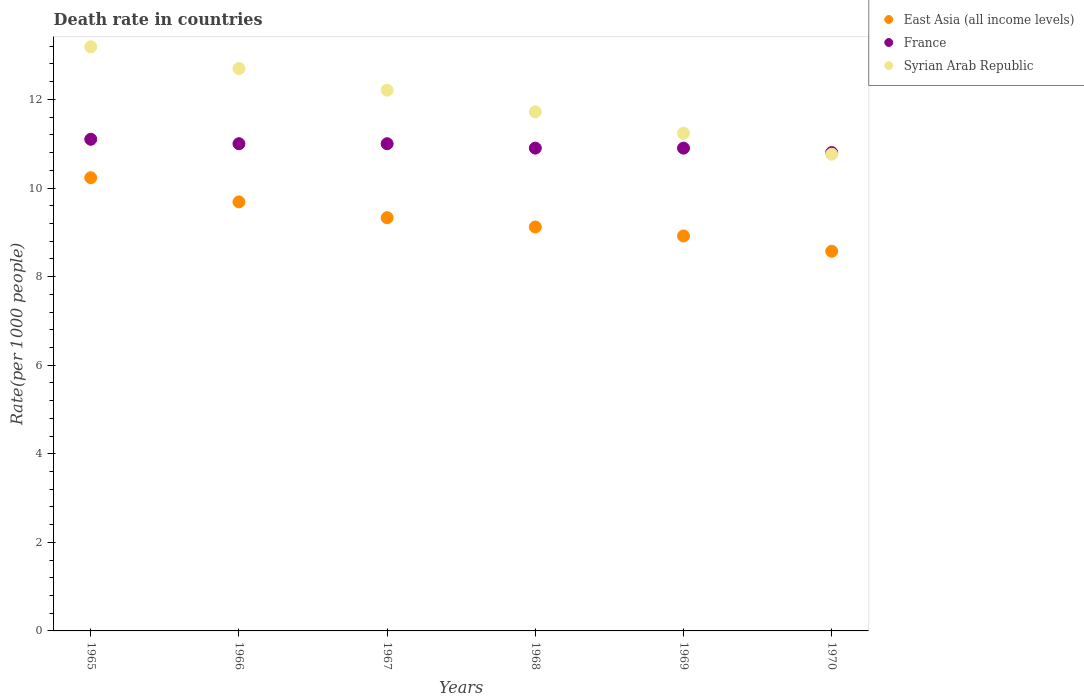What is the death rate in Syrian Arab Republic in 1965?
Offer a terse response. 13.19. Across all years, what is the maximum death rate in East Asia (all income levels)?
Make the answer very short. 10.23. In which year was the death rate in Syrian Arab Republic maximum?
Provide a succinct answer. 1965. What is the total death rate in Syrian Arab Republic in the graph?
Ensure brevity in your answer.  71.81. What is the difference between the death rate in France in 1965 and that in 1969?
Your answer should be very brief. 0.2. What is the difference between the death rate in Syrian Arab Republic in 1967 and the death rate in East Asia (all income levels) in 1968?
Your response must be concise. 3.09. What is the average death rate in Syrian Arab Republic per year?
Provide a succinct answer. 11.97. In the year 1966, what is the difference between the death rate in France and death rate in East Asia (all income levels)?
Provide a succinct answer. 1.31. In how many years, is the death rate in East Asia (all income levels) greater than 10?
Your response must be concise. 1. What is the ratio of the death rate in Syrian Arab Republic in 1966 to that in 1970?
Make the answer very short. 1.18. What is the difference between the highest and the second highest death rate in Syrian Arab Republic?
Give a very brief answer. 0.49. What is the difference between the highest and the lowest death rate in East Asia (all income levels)?
Ensure brevity in your answer.  1.66. Is the sum of the death rate in Syrian Arab Republic in 1969 and 1970 greater than the maximum death rate in France across all years?
Your answer should be very brief. Yes. Is it the case that in every year, the sum of the death rate in France and death rate in East Asia (all income levels)  is greater than the death rate in Syrian Arab Republic?
Make the answer very short. Yes. Does the death rate in East Asia (all income levels) monotonically increase over the years?
Ensure brevity in your answer.  No. Is the death rate in Syrian Arab Republic strictly greater than the death rate in France over the years?
Your response must be concise. No. Is the death rate in France strictly less than the death rate in Syrian Arab Republic over the years?
Your response must be concise. No. How many dotlines are there?
Your answer should be compact. 3. How many years are there in the graph?
Your response must be concise. 6. Where does the legend appear in the graph?
Your answer should be very brief. Top right. How are the legend labels stacked?
Your response must be concise. Vertical. What is the title of the graph?
Provide a succinct answer. Death rate in countries. What is the label or title of the Y-axis?
Your answer should be very brief. Rate(per 1000 people). What is the Rate(per 1000 people) in East Asia (all income levels) in 1965?
Give a very brief answer. 10.23. What is the Rate(per 1000 people) in Syrian Arab Republic in 1965?
Keep it short and to the point. 13.19. What is the Rate(per 1000 people) of East Asia (all income levels) in 1966?
Provide a short and direct response. 9.69. What is the Rate(per 1000 people) of Syrian Arab Republic in 1966?
Offer a terse response. 12.7. What is the Rate(per 1000 people) in East Asia (all income levels) in 1967?
Offer a terse response. 9.33. What is the Rate(per 1000 people) of France in 1967?
Give a very brief answer. 11. What is the Rate(per 1000 people) in Syrian Arab Republic in 1967?
Make the answer very short. 12.21. What is the Rate(per 1000 people) of East Asia (all income levels) in 1968?
Make the answer very short. 9.12. What is the Rate(per 1000 people) in Syrian Arab Republic in 1968?
Provide a short and direct response. 11.72. What is the Rate(per 1000 people) of East Asia (all income levels) in 1969?
Provide a succinct answer. 8.92. What is the Rate(per 1000 people) in France in 1969?
Offer a very short reply. 10.9. What is the Rate(per 1000 people) of Syrian Arab Republic in 1969?
Provide a short and direct response. 11.24. What is the Rate(per 1000 people) in East Asia (all income levels) in 1970?
Your answer should be compact. 8.57. What is the Rate(per 1000 people) in Syrian Arab Republic in 1970?
Your answer should be very brief. 10.76. Across all years, what is the maximum Rate(per 1000 people) in East Asia (all income levels)?
Make the answer very short. 10.23. Across all years, what is the maximum Rate(per 1000 people) of Syrian Arab Republic?
Provide a short and direct response. 13.19. Across all years, what is the minimum Rate(per 1000 people) of East Asia (all income levels)?
Your answer should be compact. 8.57. Across all years, what is the minimum Rate(per 1000 people) of France?
Offer a very short reply. 10.8. Across all years, what is the minimum Rate(per 1000 people) of Syrian Arab Republic?
Offer a terse response. 10.76. What is the total Rate(per 1000 people) in East Asia (all income levels) in the graph?
Provide a succinct answer. 55.86. What is the total Rate(per 1000 people) of France in the graph?
Your answer should be compact. 65.7. What is the total Rate(per 1000 people) of Syrian Arab Republic in the graph?
Give a very brief answer. 71.81. What is the difference between the Rate(per 1000 people) of East Asia (all income levels) in 1965 and that in 1966?
Your answer should be very brief. 0.55. What is the difference between the Rate(per 1000 people) in Syrian Arab Republic in 1965 and that in 1966?
Your answer should be very brief. 0.49. What is the difference between the Rate(per 1000 people) of East Asia (all income levels) in 1965 and that in 1967?
Offer a terse response. 0.9. What is the difference between the Rate(per 1000 people) in East Asia (all income levels) in 1965 and that in 1968?
Give a very brief answer. 1.11. What is the difference between the Rate(per 1000 people) in France in 1965 and that in 1968?
Your answer should be compact. 0.2. What is the difference between the Rate(per 1000 people) in Syrian Arab Republic in 1965 and that in 1968?
Provide a short and direct response. 1.47. What is the difference between the Rate(per 1000 people) in East Asia (all income levels) in 1965 and that in 1969?
Offer a very short reply. 1.32. What is the difference between the Rate(per 1000 people) of France in 1965 and that in 1969?
Offer a very short reply. 0.2. What is the difference between the Rate(per 1000 people) of Syrian Arab Republic in 1965 and that in 1969?
Your answer should be very brief. 1.95. What is the difference between the Rate(per 1000 people) in East Asia (all income levels) in 1965 and that in 1970?
Your response must be concise. 1.66. What is the difference between the Rate(per 1000 people) of Syrian Arab Republic in 1965 and that in 1970?
Offer a terse response. 2.42. What is the difference between the Rate(per 1000 people) of East Asia (all income levels) in 1966 and that in 1967?
Your response must be concise. 0.36. What is the difference between the Rate(per 1000 people) of Syrian Arab Republic in 1966 and that in 1967?
Provide a short and direct response. 0.49. What is the difference between the Rate(per 1000 people) in East Asia (all income levels) in 1966 and that in 1968?
Provide a succinct answer. 0.57. What is the difference between the Rate(per 1000 people) in East Asia (all income levels) in 1966 and that in 1969?
Make the answer very short. 0.77. What is the difference between the Rate(per 1000 people) of Syrian Arab Republic in 1966 and that in 1969?
Offer a terse response. 1.46. What is the difference between the Rate(per 1000 people) of East Asia (all income levels) in 1966 and that in 1970?
Provide a short and direct response. 1.11. What is the difference between the Rate(per 1000 people) of France in 1966 and that in 1970?
Give a very brief answer. 0.2. What is the difference between the Rate(per 1000 people) of Syrian Arab Republic in 1966 and that in 1970?
Keep it short and to the point. 1.93. What is the difference between the Rate(per 1000 people) in East Asia (all income levels) in 1967 and that in 1968?
Ensure brevity in your answer.  0.21. What is the difference between the Rate(per 1000 people) of Syrian Arab Republic in 1967 and that in 1968?
Offer a terse response. 0.49. What is the difference between the Rate(per 1000 people) of East Asia (all income levels) in 1967 and that in 1969?
Make the answer very short. 0.41. What is the difference between the Rate(per 1000 people) in France in 1967 and that in 1969?
Your answer should be compact. 0.1. What is the difference between the Rate(per 1000 people) of Syrian Arab Republic in 1967 and that in 1969?
Your answer should be compact. 0.97. What is the difference between the Rate(per 1000 people) of East Asia (all income levels) in 1967 and that in 1970?
Your answer should be very brief. 0.76. What is the difference between the Rate(per 1000 people) in Syrian Arab Republic in 1967 and that in 1970?
Your answer should be very brief. 1.45. What is the difference between the Rate(per 1000 people) of East Asia (all income levels) in 1968 and that in 1969?
Offer a very short reply. 0.2. What is the difference between the Rate(per 1000 people) in Syrian Arab Republic in 1968 and that in 1969?
Ensure brevity in your answer.  0.48. What is the difference between the Rate(per 1000 people) in East Asia (all income levels) in 1968 and that in 1970?
Offer a very short reply. 0.55. What is the difference between the Rate(per 1000 people) of France in 1968 and that in 1970?
Provide a short and direct response. 0.1. What is the difference between the Rate(per 1000 people) of East Asia (all income levels) in 1969 and that in 1970?
Your response must be concise. 0.35. What is the difference between the Rate(per 1000 people) in Syrian Arab Republic in 1969 and that in 1970?
Ensure brevity in your answer.  0.47. What is the difference between the Rate(per 1000 people) in East Asia (all income levels) in 1965 and the Rate(per 1000 people) in France in 1966?
Your answer should be compact. -0.77. What is the difference between the Rate(per 1000 people) of East Asia (all income levels) in 1965 and the Rate(per 1000 people) of Syrian Arab Republic in 1966?
Give a very brief answer. -2.46. What is the difference between the Rate(per 1000 people) of France in 1965 and the Rate(per 1000 people) of Syrian Arab Republic in 1966?
Your answer should be very brief. -1.6. What is the difference between the Rate(per 1000 people) of East Asia (all income levels) in 1965 and the Rate(per 1000 people) of France in 1967?
Keep it short and to the point. -0.77. What is the difference between the Rate(per 1000 people) of East Asia (all income levels) in 1965 and the Rate(per 1000 people) of Syrian Arab Republic in 1967?
Your answer should be compact. -1.98. What is the difference between the Rate(per 1000 people) in France in 1965 and the Rate(per 1000 people) in Syrian Arab Republic in 1967?
Make the answer very short. -1.11. What is the difference between the Rate(per 1000 people) in East Asia (all income levels) in 1965 and the Rate(per 1000 people) in France in 1968?
Offer a terse response. -0.67. What is the difference between the Rate(per 1000 people) in East Asia (all income levels) in 1965 and the Rate(per 1000 people) in Syrian Arab Republic in 1968?
Offer a terse response. -1.49. What is the difference between the Rate(per 1000 people) in France in 1965 and the Rate(per 1000 people) in Syrian Arab Republic in 1968?
Provide a succinct answer. -0.62. What is the difference between the Rate(per 1000 people) of East Asia (all income levels) in 1965 and the Rate(per 1000 people) of France in 1969?
Make the answer very short. -0.67. What is the difference between the Rate(per 1000 people) of East Asia (all income levels) in 1965 and the Rate(per 1000 people) of Syrian Arab Republic in 1969?
Your answer should be very brief. -1. What is the difference between the Rate(per 1000 people) of France in 1965 and the Rate(per 1000 people) of Syrian Arab Republic in 1969?
Give a very brief answer. -0.14. What is the difference between the Rate(per 1000 people) in East Asia (all income levels) in 1965 and the Rate(per 1000 people) in France in 1970?
Your response must be concise. -0.57. What is the difference between the Rate(per 1000 people) of East Asia (all income levels) in 1965 and the Rate(per 1000 people) of Syrian Arab Republic in 1970?
Offer a very short reply. -0.53. What is the difference between the Rate(per 1000 people) in France in 1965 and the Rate(per 1000 people) in Syrian Arab Republic in 1970?
Offer a very short reply. 0.34. What is the difference between the Rate(per 1000 people) of East Asia (all income levels) in 1966 and the Rate(per 1000 people) of France in 1967?
Your answer should be compact. -1.31. What is the difference between the Rate(per 1000 people) in East Asia (all income levels) in 1966 and the Rate(per 1000 people) in Syrian Arab Republic in 1967?
Offer a terse response. -2.52. What is the difference between the Rate(per 1000 people) of France in 1966 and the Rate(per 1000 people) of Syrian Arab Republic in 1967?
Offer a very short reply. -1.21. What is the difference between the Rate(per 1000 people) of East Asia (all income levels) in 1966 and the Rate(per 1000 people) of France in 1968?
Provide a succinct answer. -1.21. What is the difference between the Rate(per 1000 people) of East Asia (all income levels) in 1966 and the Rate(per 1000 people) of Syrian Arab Republic in 1968?
Offer a terse response. -2.03. What is the difference between the Rate(per 1000 people) of France in 1966 and the Rate(per 1000 people) of Syrian Arab Republic in 1968?
Your response must be concise. -0.72. What is the difference between the Rate(per 1000 people) in East Asia (all income levels) in 1966 and the Rate(per 1000 people) in France in 1969?
Your response must be concise. -1.21. What is the difference between the Rate(per 1000 people) in East Asia (all income levels) in 1966 and the Rate(per 1000 people) in Syrian Arab Republic in 1969?
Offer a very short reply. -1.55. What is the difference between the Rate(per 1000 people) in France in 1966 and the Rate(per 1000 people) in Syrian Arab Republic in 1969?
Give a very brief answer. -0.24. What is the difference between the Rate(per 1000 people) of East Asia (all income levels) in 1966 and the Rate(per 1000 people) of France in 1970?
Keep it short and to the point. -1.11. What is the difference between the Rate(per 1000 people) in East Asia (all income levels) in 1966 and the Rate(per 1000 people) in Syrian Arab Republic in 1970?
Offer a very short reply. -1.08. What is the difference between the Rate(per 1000 people) in France in 1966 and the Rate(per 1000 people) in Syrian Arab Republic in 1970?
Provide a short and direct response. 0.24. What is the difference between the Rate(per 1000 people) of East Asia (all income levels) in 1967 and the Rate(per 1000 people) of France in 1968?
Offer a very short reply. -1.57. What is the difference between the Rate(per 1000 people) of East Asia (all income levels) in 1967 and the Rate(per 1000 people) of Syrian Arab Republic in 1968?
Your answer should be very brief. -2.39. What is the difference between the Rate(per 1000 people) in France in 1967 and the Rate(per 1000 people) in Syrian Arab Republic in 1968?
Provide a short and direct response. -0.72. What is the difference between the Rate(per 1000 people) in East Asia (all income levels) in 1967 and the Rate(per 1000 people) in France in 1969?
Provide a short and direct response. -1.57. What is the difference between the Rate(per 1000 people) of East Asia (all income levels) in 1967 and the Rate(per 1000 people) of Syrian Arab Republic in 1969?
Your answer should be very brief. -1.91. What is the difference between the Rate(per 1000 people) of France in 1967 and the Rate(per 1000 people) of Syrian Arab Republic in 1969?
Offer a very short reply. -0.24. What is the difference between the Rate(per 1000 people) of East Asia (all income levels) in 1967 and the Rate(per 1000 people) of France in 1970?
Offer a very short reply. -1.47. What is the difference between the Rate(per 1000 people) in East Asia (all income levels) in 1967 and the Rate(per 1000 people) in Syrian Arab Republic in 1970?
Make the answer very short. -1.43. What is the difference between the Rate(per 1000 people) in France in 1967 and the Rate(per 1000 people) in Syrian Arab Republic in 1970?
Offer a terse response. 0.24. What is the difference between the Rate(per 1000 people) in East Asia (all income levels) in 1968 and the Rate(per 1000 people) in France in 1969?
Offer a very short reply. -1.78. What is the difference between the Rate(per 1000 people) of East Asia (all income levels) in 1968 and the Rate(per 1000 people) of Syrian Arab Republic in 1969?
Offer a terse response. -2.12. What is the difference between the Rate(per 1000 people) of France in 1968 and the Rate(per 1000 people) of Syrian Arab Republic in 1969?
Make the answer very short. -0.34. What is the difference between the Rate(per 1000 people) of East Asia (all income levels) in 1968 and the Rate(per 1000 people) of France in 1970?
Offer a terse response. -1.68. What is the difference between the Rate(per 1000 people) in East Asia (all income levels) in 1968 and the Rate(per 1000 people) in Syrian Arab Republic in 1970?
Make the answer very short. -1.64. What is the difference between the Rate(per 1000 people) in France in 1968 and the Rate(per 1000 people) in Syrian Arab Republic in 1970?
Make the answer very short. 0.14. What is the difference between the Rate(per 1000 people) of East Asia (all income levels) in 1969 and the Rate(per 1000 people) of France in 1970?
Offer a terse response. -1.88. What is the difference between the Rate(per 1000 people) in East Asia (all income levels) in 1969 and the Rate(per 1000 people) in Syrian Arab Republic in 1970?
Your response must be concise. -1.85. What is the difference between the Rate(per 1000 people) in France in 1969 and the Rate(per 1000 people) in Syrian Arab Republic in 1970?
Offer a terse response. 0.14. What is the average Rate(per 1000 people) in East Asia (all income levels) per year?
Offer a terse response. 9.31. What is the average Rate(per 1000 people) in France per year?
Provide a succinct answer. 10.95. What is the average Rate(per 1000 people) of Syrian Arab Republic per year?
Your response must be concise. 11.97. In the year 1965, what is the difference between the Rate(per 1000 people) of East Asia (all income levels) and Rate(per 1000 people) of France?
Ensure brevity in your answer.  -0.87. In the year 1965, what is the difference between the Rate(per 1000 people) of East Asia (all income levels) and Rate(per 1000 people) of Syrian Arab Republic?
Your answer should be compact. -2.96. In the year 1965, what is the difference between the Rate(per 1000 people) in France and Rate(per 1000 people) in Syrian Arab Republic?
Offer a very short reply. -2.09. In the year 1966, what is the difference between the Rate(per 1000 people) of East Asia (all income levels) and Rate(per 1000 people) of France?
Your answer should be very brief. -1.31. In the year 1966, what is the difference between the Rate(per 1000 people) of East Asia (all income levels) and Rate(per 1000 people) of Syrian Arab Republic?
Give a very brief answer. -3.01. In the year 1966, what is the difference between the Rate(per 1000 people) of France and Rate(per 1000 people) of Syrian Arab Republic?
Offer a terse response. -1.7. In the year 1967, what is the difference between the Rate(per 1000 people) in East Asia (all income levels) and Rate(per 1000 people) in France?
Make the answer very short. -1.67. In the year 1967, what is the difference between the Rate(per 1000 people) of East Asia (all income levels) and Rate(per 1000 people) of Syrian Arab Republic?
Make the answer very short. -2.88. In the year 1967, what is the difference between the Rate(per 1000 people) in France and Rate(per 1000 people) in Syrian Arab Republic?
Provide a short and direct response. -1.21. In the year 1968, what is the difference between the Rate(per 1000 people) of East Asia (all income levels) and Rate(per 1000 people) of France?
Your answer should be very brief. -1.78. In the year 1968, what is the difference between the Rate(per 1000 people) in East Asia (all income levels) and Rate(per 1000 people) in Syrian Arab Republic?
Your response must be concise. -2.6. In the year 1968, what is the difference between the Rate(per 1000 people) in France and Rate(per 1000 people) in Syrian Arab Republic?
Offer a very short reply. -0.82. In the year 1969, what is the difference between the Rate(per 1000 people) in East Asia (all income levels) and Rate(per 1000 people) in France?
Offer a very short reply. -1.98. In the year 1969, what is the difference between the Rate(per 1000 people) in East Asia (all income levels) and Rate(per 1000 people) in Syrian Arab Republic?
Provide a succinct answer. -2.32. In the year 1969, what is the difference between the Rate(per 1000 people) in France and Rate(per 1000 people) in Syrian Arab Republic?
Ensure brevity in your answer.  -0.34. In the year 1970, what is the difference between the Rate(per 1000 people) of East Asia (all income levels) and Rate(per 1000 people) of France?
Keep it short and to the point. -2.23. In the year 1970, what is the difference between the Rate(per 1000 people) in East Asia (all income levels) and Rate(per 1000 people) in Syrian Arab Republic?
Your answer should be very brief. -2.19. In the year 1970, what is the difference between the Rate(per 1000 people) in France and Rate(per 1000 people) in Syrian Arab Republic?
Give a very brief answer. 0.04. What is the ratio of the Rate(per 1000 people) in East Asia (all income levels) in 1965 to that in 1966?
Your answer should be very brief. 1.06. What is the ratio of the Rate(per 1000 people) in France in 1965 to that in 1966?
Your answer should be compact. 1.01. What is the ratio of the Rate(per 1000 people) in Syrian Arab Republic in 1965 to that in 1966?
Give a very brief answer. 1.04. What is the ratio of the Rate(per 1000 people) in East Asia (all income levels) in 1965 to that in 1967?
Your response must be concise. 1.1. What is the ratio of the Rate(per 1000 people) of France in 1965 to that in 1967?
Your answer should be compact. 1.01. What is the ratio of the Rate(per 1000 people) in Syrian Arab Republic in 1965 to that in 1967?
Offer a terse response. 1.08. What is the ratio of the Rate(per 1000 people) in East Asia (all income levels) in 1965 to that in 1968?
Offer a very short reply. 1.12. What is the ratio of the Rate(per 1000 people) of France in 1965 to that in 1968?
Your answer should be compact. 1.02. What is the ratio of the Rate(per 1000 people) of Syrian Arab Republic in 1965 to that in 1968?
Provide a short and direct response. 1.13. What is the ratio of the Rate(per 1000 people) of East Asia (all income levels) in 1965 to that in 1969?
Provide a succinct answer. 1.15. What is the ratio of the Rate(per 1000 people) of France in 1965 to that in 1969?
Provide a succinct answer. 1.02. What is the ratio of the Rate(per 1000 people) in Syrian Arab Republic in 1965 to that in 1969?
Make the answer very short. 1.17. What is the ratio of the Rate(per 1000 people) in East Asia (all income levels) in 1965 to that in 1970?
Keep it short and to the point. 1.19. What is the ratio of the Rate(per 1000 people) of France in 1965 to that in 1970?
Offer a terse response. 1.03. What is the ratio of the Rate(per 1000 people) in Syrian Arab Republic in 1965 to that in 1970?
Ensure brevity in your answer.  1.23. What is the ratio of the Rate(per 1000 people) in East Asia (all income levels) in 1966 to that in 1967?
Your response must be concise. 1.04. What is the ratio of the Rate(per 1000 people) of France in 1966 to that in 1967?
Provide a short and direct response. 1. What is the ratio of the Rate(per 1000 people) of Syrian Arab Republic in 1966 to that in 1967?
Offer a terse response. 1.04. What is the ratio of the Rate(per 1000 people) in East Asia (all income levels) in 1966 to that in 1968?
Provide a succinct answer. 1.06. What is the ratio of the Rate(per 1000 people) in France in 1966 to that in 1968?
Keep it short and to the point. 1.01. What is the ratio of the Rate(per 1000 people) of Syrian Arab Republic in 1966 to that in 1968?
Provide a short and direct response. 1.08. What is the ratio of the Rate(per 1000 people) of East Asia (all income levels) in 1966 to that in 1969?
Give a very brief answer. 1.09. What is the ratio of the Rate(per 1000 people) of France in 1966 to that in 1969?
Your answer should be very brief. 1.01. What is the ratio of the Rate(per 1000 people) in Syrian Arab Republic in 1966 to that in 1969?
Keep it short and to the point. 1.13. What is the ratio of the Rate(per 1000 people) of East Asia (all income levels) in 1966 to that in 1970?
Offer a very short reply. 1.13. What is the ratio of the Rate(per 1000 people) of France in 1966 to that in 1970?
Your response must be concise. 1.02. What is the ratio of the Rate(per 1000 people) in Syrian Arab Republic in 1966 to that in 1970?
Offer a terse response. 1.18. What is the ratio of the Rate(per 1000 people) in France in 1967 to that in 1968?
Give a very brief answer. 1.01. What is the ratio of the Rate(per 1000 people) in Syrian Arab Republic in 1967 to that in 1968?
Offer a very short reply. 1.04. What is the ratio of the Rate(per 1000 people) of East Asia (all income levels) in 1967 to that in 1969?
Offer a terse response. 1.05. What is the ratio of the Rate(per 1000 people) in France in 1967 to that in 1969?
Offer a terse response. 1.01. What is the ratio of the Rate(per 1000 people) of Syrian Arab Republic in 1967 to that in 1969?
Your response must be concise. 1.09. What is the ratio of the Rate(per 1000 people) of East Asia (all income levels) in 1967 to that in 1970?
Ensure brevity in your answer.  1.09. What is the ratio of the Rate(per 1000 people) in France in 1967 to that in 1970?
Your answer should be very brief. 1.02. What is the ratio of the Rate(per 1000 people) of Syrian Arab Republic in 1967 to that in 1970?
Your response must be concise. 1.13. What is the ratio of the Rate(per 1000 people) of East Asia (all income levels) in 1968 to that in 1969?
Ensure brevity in your answer.  1.02. What is the ratio of the Rate(per 1000 people) in France in 1968 to that in 1969?
Give a very brief answer. 1. What is the ratio of the Rate(per 1000 people) of Syrian Arab Republic in 1968 to that in 1969?
Provide a short and direct response. 1.04. What is the ratio of the Rate(per 1000 people) of East Asia (all income levels) in 1968 to that in 1970?
Your answer should be very brief. 1.06. What is the ratio of the Rate(per 1000 people) of France in 1968 to that in 1970?
Provide a succinct answer. 1.01. What is the ratio of the Rate(per 1000 people) of Syrian Arab Republic in 1968 to that in 1970?
Offer a very short reply. 1.09. What is the ratio of the Rate(per 1000 people) of East Asia (all income levels) in 1969 to that in 1970?
Keep it short and to the point. 1.04. What is the ratio of the Rate(per 1000 people) of France in 1969 to that in 1970?
Make the answer very short. 1.01. What is the ratio of the Rate(per 1000 people) in Syrian Arab Republic in 1969 to that in 1970?
Offer a very short reply. 1.04. What is the difference between the highest and the second highest Rate(per 1000 people) in East Asia (all income levels)?
Your answer should be very brief. 0.55. What is the difference between the highest and the second highest Rate(per 1000 people) in Syrian Arab Republic?
Keep it short and to the point. 0.49. What is the difference between the highest and the lowest Rate(per 1000 people) of East Asia (all income levels)?
Offer a terse response. 1.66. What is the difference between the highest and the lowest Rate(per 1000 people) of France?
Provide a short and direct response. 0.3. What is the difference between the highest and the lowest Rate(per 1000 people) in Syrian Arab Republic?
Keep it short and to the point. 2.42. 